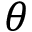Convert formula to latex. <formula><loc_0><loc_0><loc_500><loc_500>\theta</formula> 